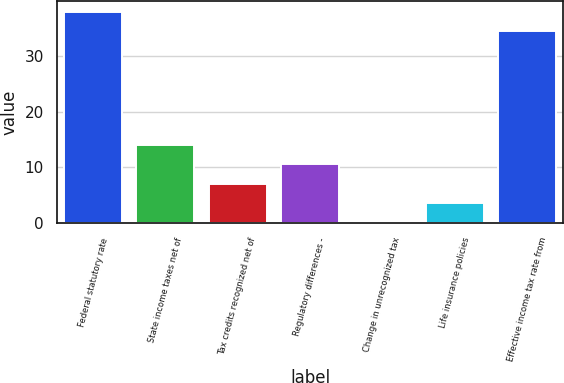Convert chart to OTSL. <chart><loc_0><loc_0><loc_500><loc_500><bar_chart><fcel>Federal statutory rate<fcel>State income taxes net of<fcel>Tax credits recognized net of<fcel>Regulatory differences -<fcel>Change in unrecognized tax<fcel>Life insurance policies<fcel>Effective income tax rate from<nl><fcel>37.89<fcel>14.06<fcel>7.08<fcel>10.57<fcel>0.1<fcel>3.59<fcel>34.4<nl></chart> 